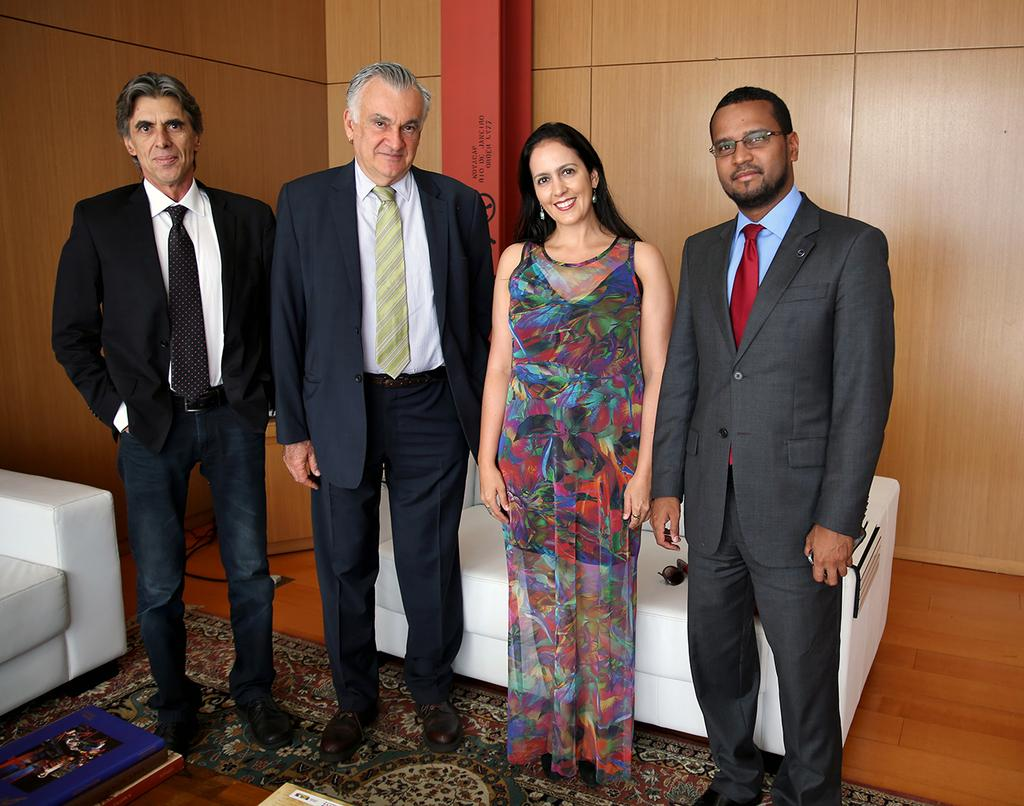What can be seen in the image? There are people standing in the image. What is visible in the background of the image? There are sofas and a wall in the background of the image. What is at the bottom of the image? There is a carpet at the bottom of the image. What type of fuel is being used by the people in the image? There is no mention of fuel or any related objects in the image, so it cannot be determined. 